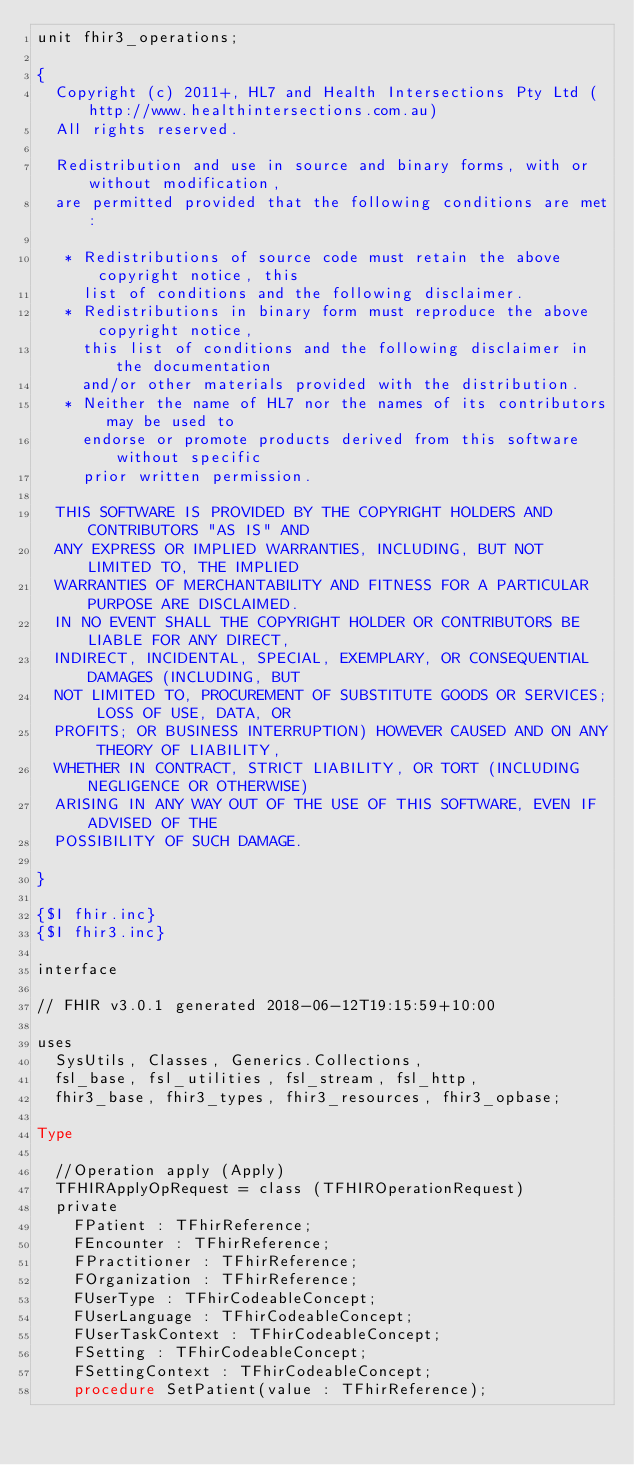<code> <loc_0><loc_0><loc_500><loc_500><_Pascal_>unit fhir3_operations;

{
  Copyright (c) 2011+, HL7 and Health Intersections Pty Ltd (http://www.healthintersections.com.au)
  All rights reserved.

  Redistribution and use in source and binary forms, with or without modification,
  are permitted provided that the following conditions are met:

   * Redistributions of source code must retain the above copyright notice, this
     list of conditions and the following disclaimer.
   * Redistributions in binary form must reproduce the above copyright notice,
     this list of conditions and the following disclaimer in the documentation
     and/or other materials provided with the distribution.
   * Neither the name of HL7 nor the names of its contributors may be used to
     endorse or promote products derived from this software without specific
     prior written permission.

  THIS SOFTWARE IS PROVIDED BY THE COPYRIGHT HOLDERS AND CONTRIBUTORS "AS IS" AND
  ANY EXPRESS OR IMPLIED WARRANTIES, INCLUDING, BUT NOT LIMITED TO, THE IMPLIED
  WARRANTIES OF MERCHANTABILITY AND FITNESS FOR A PARTICULAR PURPOSE ARE DISCLAIMED.
  IN NO EVENT SHALL THE COPYRIGHT HOLDER OR CONTRIBUTORS BE LIABLE FOR ANY DIRECT,
  INDIRECT, INCIDENTAL, SPECIAL, EXEMPLARY, OR CONSEQUENTIAL DAMAGES (INCLUDING, BUT
  NOT LIMITED TO, PROCUREMENT OF SUBSTITUTE GOODS OR SERVICES; LOSS OF USE, DATA, OR
  PROFITS; OR BUSINESS INTERRUPTION) HOWEVER CAUSED AND ON ANY THEORY OF LIABILITY,
  WHETHER IN CONTRACT, STRICT LIABILITY, OR TORT (INCLUDING NEGLIGENCE OR OTHERWISE)
  ARISING IN ANY WAY OUT OF THE USE OF THIS SOFTWARE, EVEN IF ADVISED OF THE
  POSSIBILITY OF SUCH DAMAGE.

}

{$I fhir.inc}
{$I fhir3.inc}

interface

// FHIR v3.0.1 generated 2018-06-12T19:15:59+10:00

uses
  SysUtils, Classes, Generics.Collections, 
  fsl_base, fsl_utilities, fsl_stream, fsl_http, 
  fhir3_base, fhir3_types, fhir3_resources, fhir3_opbase;

Type

  //Operation apply (Apply)
  TFHIRApplyOpRequest = class (TFHIROperationRequest)
  private
    FPatient : TFhirReference;
    FEncounter : TFhirReference;
    FPractitioner : TFhirReference;
    FOrganization : TFhirReference;
    FUserType : TFhirCodeableConcept;
    FUserLanguage : TFhirCodeableConcept;
    FUserTaskContext : TFhirCodeableConcept;
    FSetting : TFhirCodeableConcept;
    FSettingContext : TFhirCodeableConcept;
    procedure SetPatient(value : TFhirReference);</code> 